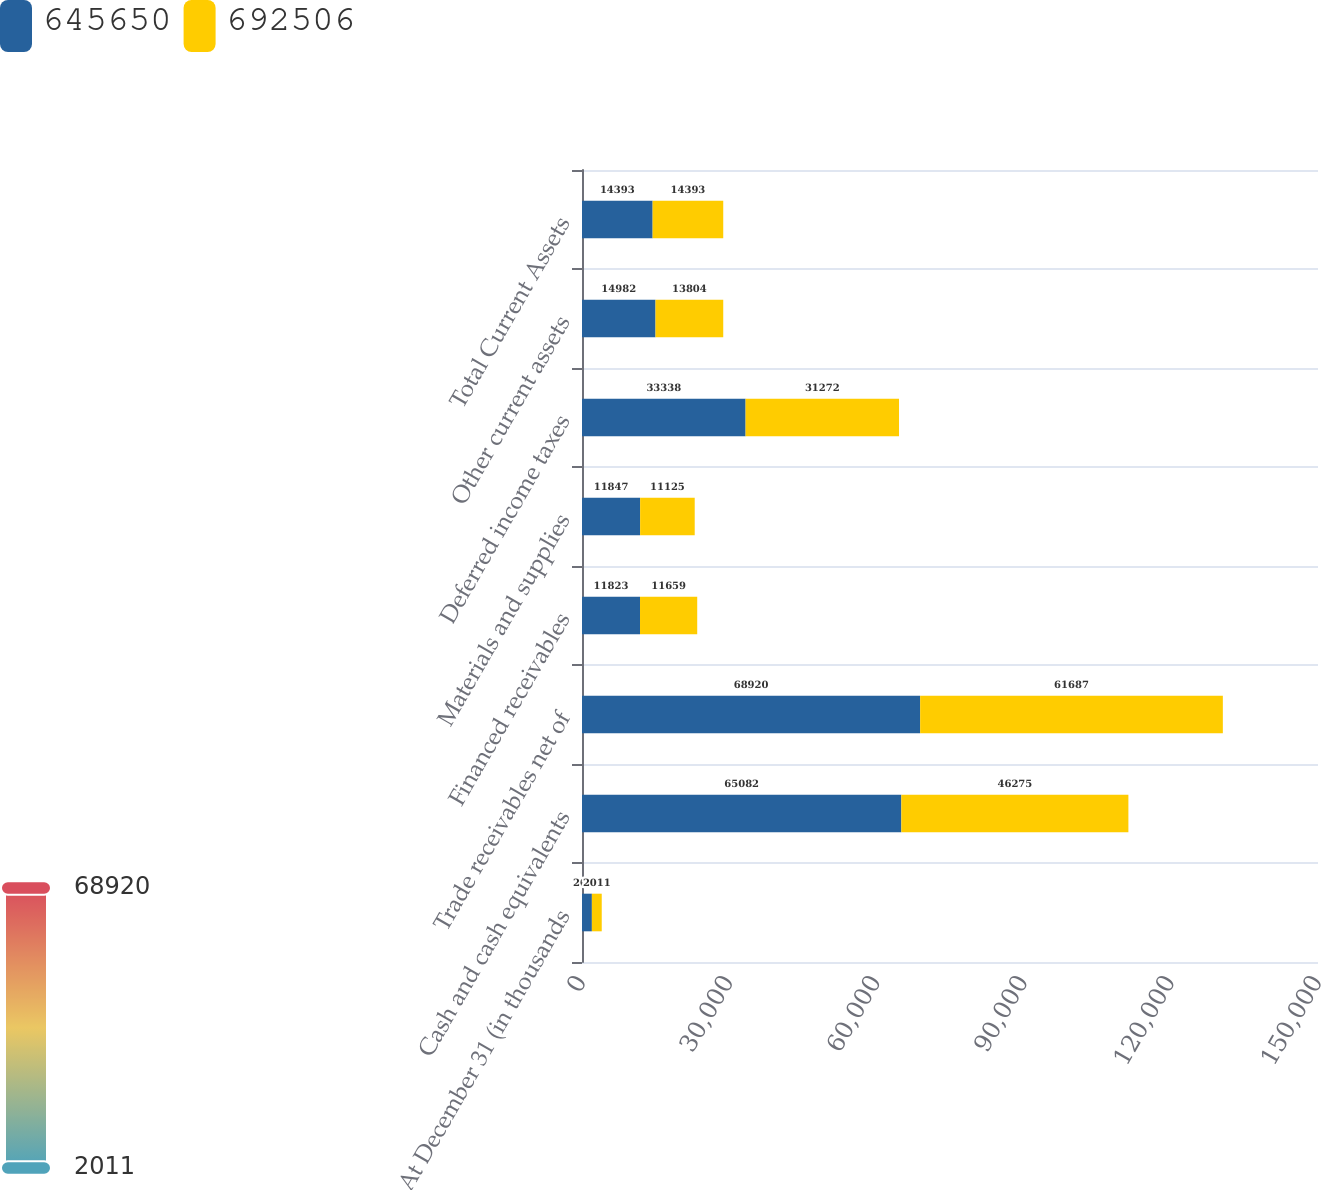Convert chart to OTSL. <chart><loc_0><loc_0><loc_500><loc_500><stacked_bar_chart><ecel><fcel>At December 31 (in thousands<fcel>Cash and cash equivalents<fcel>Trade receivables net of<fcel>Financed receivables<fcel>Materials and supplies<fcel>Deferred income taxes<fcel>Other current assets<fcel>Total Current Assets<nl><fcel>645650<fcel>2012<fcel>65082<fcel>68920<fcel>11823<fcel>11847<fcel>33338<fcel>14982<fcel>14393<nl><fcel>692506<fcel>2011<fcel>46275<fcel>61687<fcel>11659<fcel>11125<fcel>31272<fcel>13804<fcel>14393<nl></chart> 